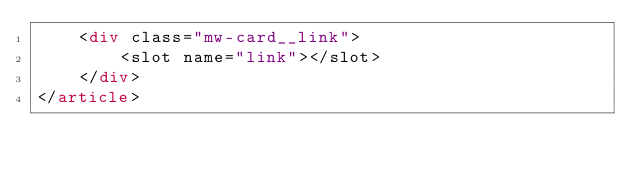<code> <loc_0><loc_0><loc_500><loc_500><_HTML_>    <div class="mw-card__link">
        <slot name="link"></slot>
    </div>
</article>
</code> 